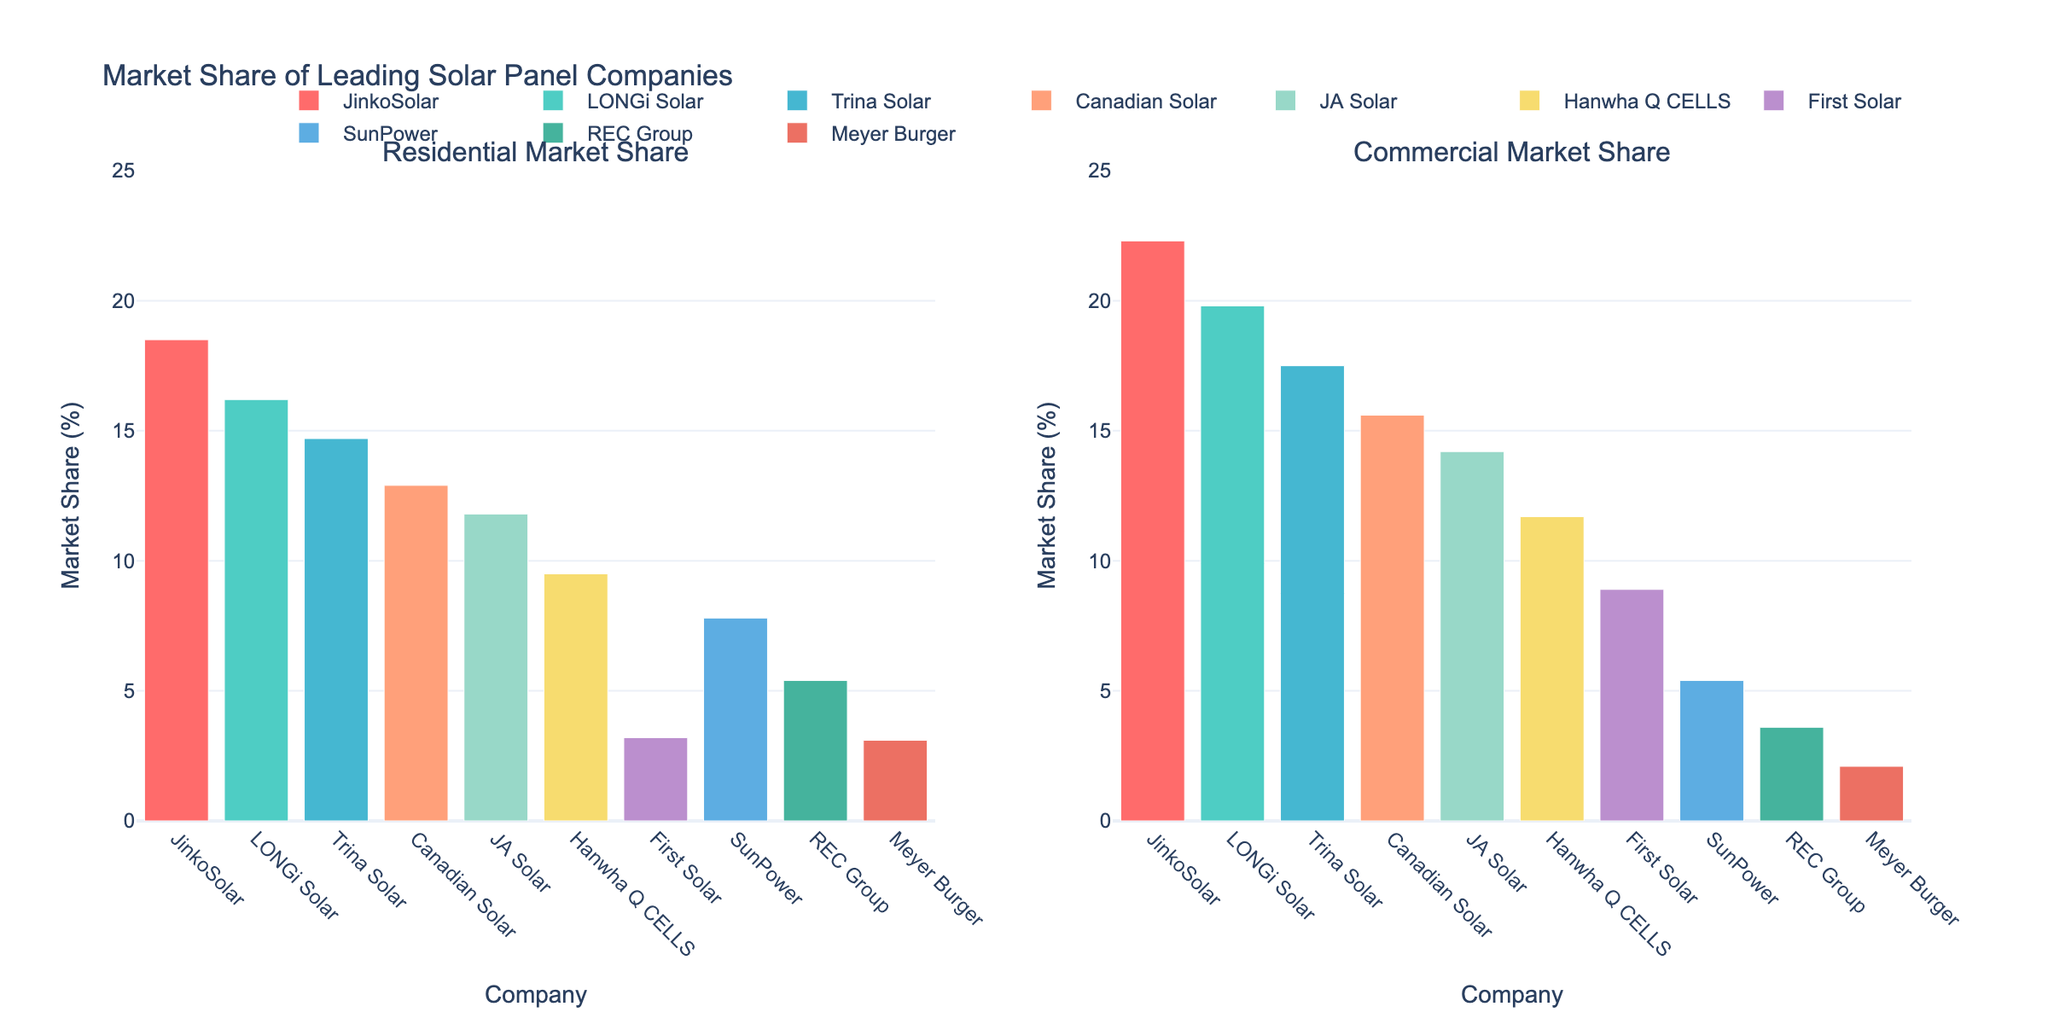What's the title of the figure? The title of the figure is located at the top center of the plot and is prominently displayed.
Answer: Market Share of Leading Solar Panel Companies What's the market share percentage for JinkoSolar in residential installations? Find the bar for JinkoSolar in the "Residential Market Share" subplot and read its value from the y-axis.
Answer: 18.5% Which company has the highest commercial market share? Look at the "Commercial Market Share" subplot and identify the bar that reaches the highest value on the y-axis.
Answer: JinkoSolar How many companies have a higher market share in residential installations compared to commercial installations? For each company, check if the bar in the "Residential Market Share" subplot is taller than the bar in the "Commercial Market Share" subplot. Count the number of such companies.
Answer: 7 What's the total market share percentage of the top three companies in residential installations? Sum the residential market share percentages of JinkoSolar, LONGi Solar, and Trina Solar.
Answer: 18.5 + 16.2 + 14.7 = 49.4% Which company has the greatest difference between residential and commercial market share? Calculate the absolute difference between the residential and commercial market share percentages for each company and find the largest difference.
Answer: SunPower What's the average commercial market share percentage of all companies? Sum the commercial market share percentages of all companies and divide by the number of companies (10).
Answer: (22.3 + 19.8 + 17.5 + 15.6 + 14.2 + 11.7 + 8.9 + 5.4 + 3.6 + 2.1) / 10 = 121.1 / 10 = 12.11% Which company has the smallest market share in residential installations? Look at the "Residential Market Share" subplot and identify the bar that reaches the lowest value on the y-axis.
Answer: Meyer Burger What is the combined market share percentage of Hanwha Q CELLS in both residential and commercial installations? Add the residential and commercial market share percentages of Hanwha Q CELLS.
Answer: 9.5 + 11.7 = 21.2% How does the market share of REC Group in commercial installations compare to its residential market share? Compare the heights of the bars for REC Group in both subplots.
Answer: REC Group's commercial market share (3.6%) is lower than its residential market share (5.4%) 